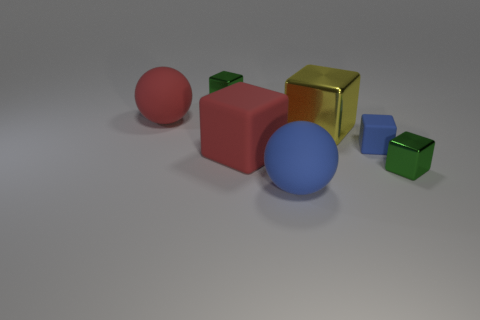Subtract all red cubes. How many cubes are left? 4 Subtract all yellow blocks. How many blocks are left? 4 Subtract 1 blocks. How many blocks are left? 4 Add 2 tiny red metallic things. How many objects exist? 9 Subtract all yellow cubes. Subtract all gray balls. How many cubes are left? 4 Subtract all spheres. How many objects are left? 5 Add 5 metallic cubes. How many metallic cubes are left? 8 Add 2 small shiny things. How many small shiny things exist? 4 Subtract 0 blue cylinders. How many objects are left? 7 Subtract all large yellow objects. Subtract all small blue rubber blocks. How many objects are left? 5 